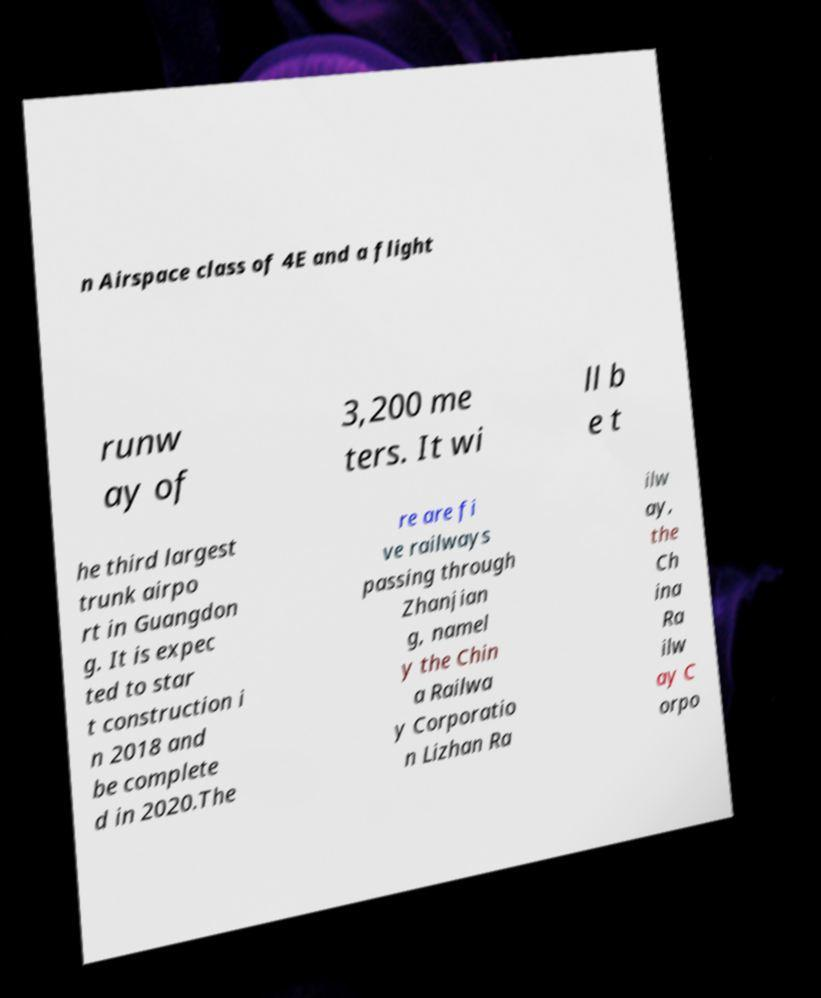I need the written content from this picture converted into text. Can you do that? n Airspace class of 4E and a flight runw ay of 3,200 me ters. It wi ll b e t he third largest trunk airpo rt in Guangdon g. It is expec ted to star t construction i n 2018 and be complete d in 2020.The re are fi ve railways passing through Zhanjian g, namel y the Chin a Railwa y Corporatio n Lizhan Ra ilw ay, the Ch ina Ra ilw ay C orpo 